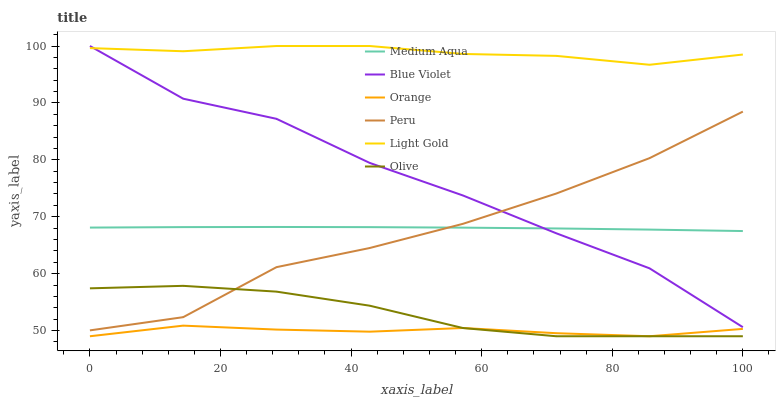Does Orange have the minimum area under the curve?
Answer yes or no. Yes. Does Light Gold have the maximum area under the curve?
Answer yes or no. Yes. Does Medium Aqua have the minimum area under the curve?
Answer yes or no. No. Does Medium Aqua have the maximum area under the curve?
Answer yes or no. No. Is Medium Aqua the smoothest?
Answer yes or no. Yes. Is Blue Violet the roughest?
Answer yes or no. Yes. Is Peru the smoothest?
Answer yes or no. No. Is Peru the roughest?
Answer yes or no. No. Does Olive have the lowest value?
Answer yes or no. Yes. Does Medium Aqua have the lowest value?
Answer yes or no. No. Does Blue Violet have the highest value?
Answer yes or no. Yes. Does Medium Aqua have the highest value?
Answer yes or no. No. Is Peru less than Light Gold?
Answer yes or no. Yes. Is Medium Aqua greater than Olive?
Answer yes or no. Yes. Does Blue Violet intersect Light Gold?
Answer yes or no. Yes. Is Blue Violet less than Light Gold?
Answer yes or no. No. Is Blue Violet greater than Light Gold?
Answer yes or no. No. Does Peru intersect Light Gold?
Answer yes or no. No. 